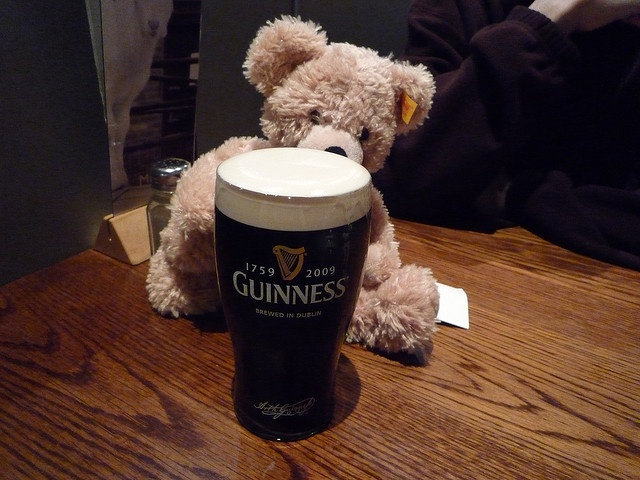Describe the objects in this image and their specific colors. I can see dining table in black, maroon, brown, and gray tones, people in black, darkgray, and gray tones, teddy bear in black, tan, gray, and maroon tones, cup in black, ivory, and gray tones, and chair in black, gray, and darkgray tones in this image. 